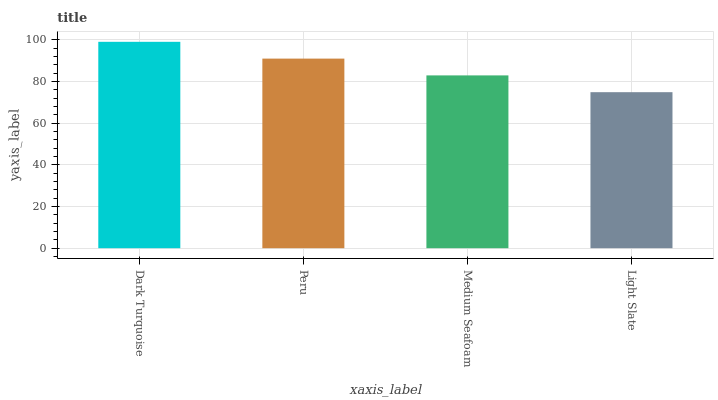Is Light Slate the minimum?
Answer yes or no. Yes. Is Dark Turquoise the maximum?
Answer yes or no. Yes. Is Peru the minimum?
Answer yes or no. No. Is Peru the maximum?
Answer yes or no. No. Is Dark Turquoise greater than Peru?
Answer yes or no. Yes. Is Peru less than Dark Turquoise?
Answer yes or no. Yes. Is Peru greater than Dark Turquoise?
Answer yes or no. No. Is Dark Turquoise less than Peru?
Answer yes or no. No. Is Peru the high median?
Answer yes or no. Yes. Is Medium Seafoam the low median?
Answer yes or no. Yes. Is Light Slate the high median?
Answer yes or no. No. Is Dark Turquoise the low median?
Answer yes or no. No. 